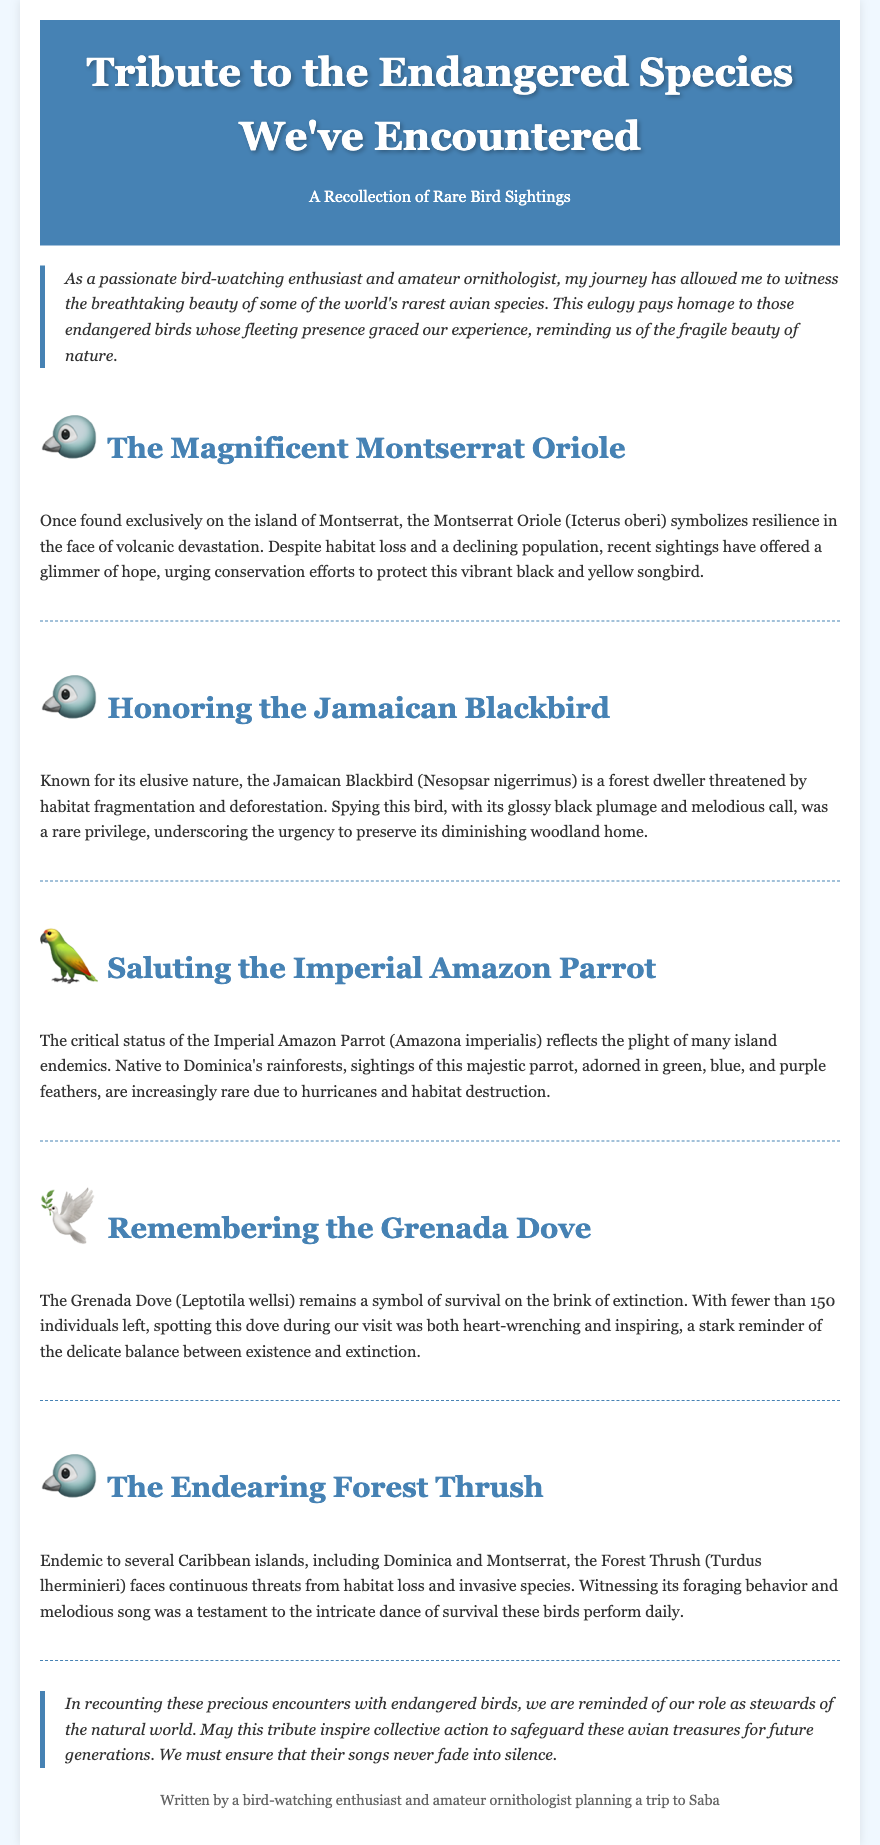what is the title of the document? The title is prominently displayed in the header section of the document.
Answer: Tribute to the Endangered Species We've Encountered who is the author of the eulogy? The author is introduced at the end of the document in the footer.
Answer: bird-watching enthusiast and amateur ornithologist how many individuals are left of the Grenada Dove? The number of individuals remaining is specified in the paragraph dedicated to the Grenada Dove.
Answer: fewer than 150 which bird symbolizes resilience in the face of volcanic devastation? This symbolism is mentioned in the section about the Montserrat Oriole.
Answer: The Magnificent Montserrat Oriole what is the critical status of the Imperial Amazon Parrot related to? The status reflects the threats faced by the species as discussed in its section.
Answer: hurricanes and habitat destruction what message does the conclusion convey? The conclusion emphasizes the importance of conservation based on ideas presented in the eulogy.
Answer: safeguard these avian treasures how are the Jamaican Blackbird and Forest Thrush threatened? Both birds face threats due to environmental challenges mentioned in their respective sections.
Answer: habitat fragmentation and loss 